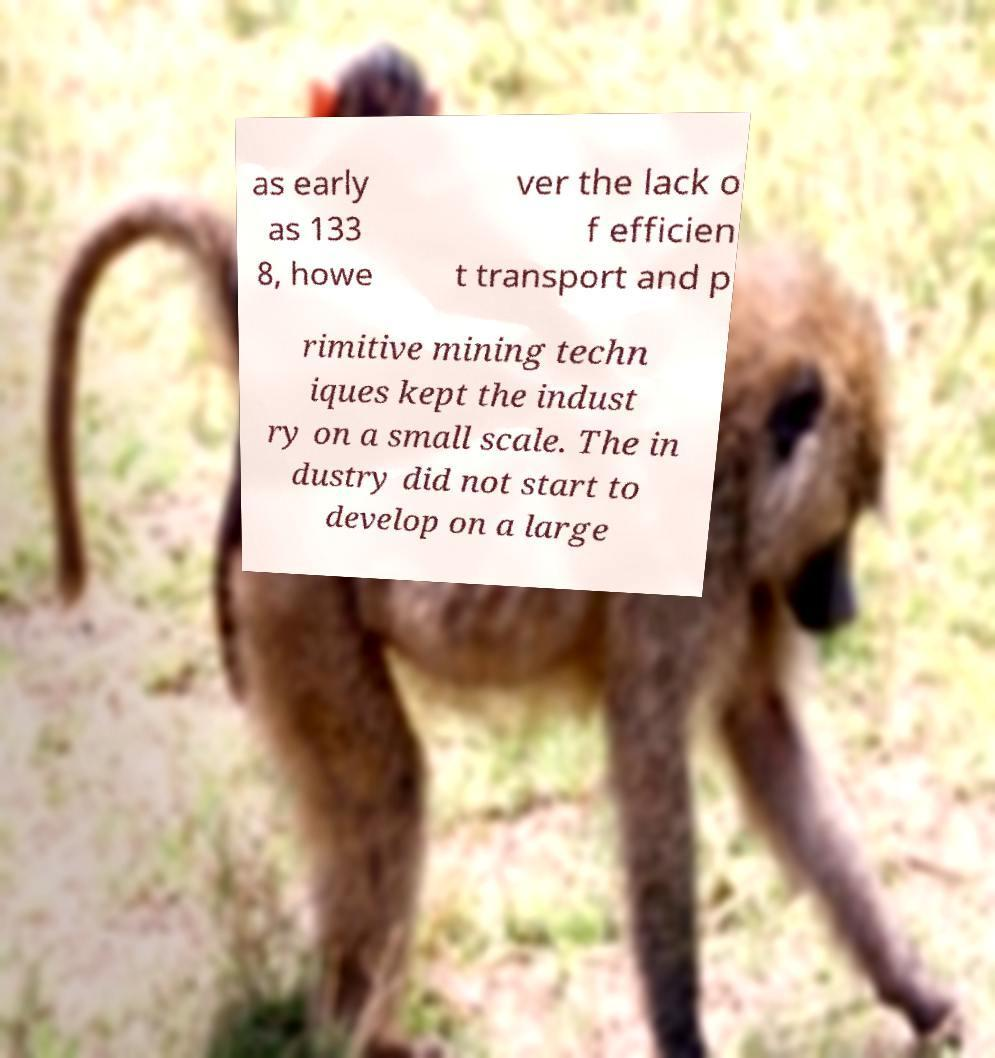Please identify and transcribe the text found in this image. as early as 133 8, howe ver the lack o f efficien t transport and p rimitive mining techn iques kept the indust ry on a small scale. The in dustry did not start to develop on a large 